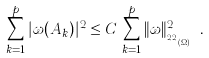Convert formula to latex. <formula><loc_0><loc_0><loc_500><loc_500>\sum _ { k = 1 } ^ { p } | \omega ( A _ { k } ) | ^ { 2 } \leq C \, \sum _ { k = 1 } ^ { p } \| \omega \| _ { _ { H _ { \beta } ^ { 2 , 2 } ( \Omega ) } } ^ { 2 } .</formula> 